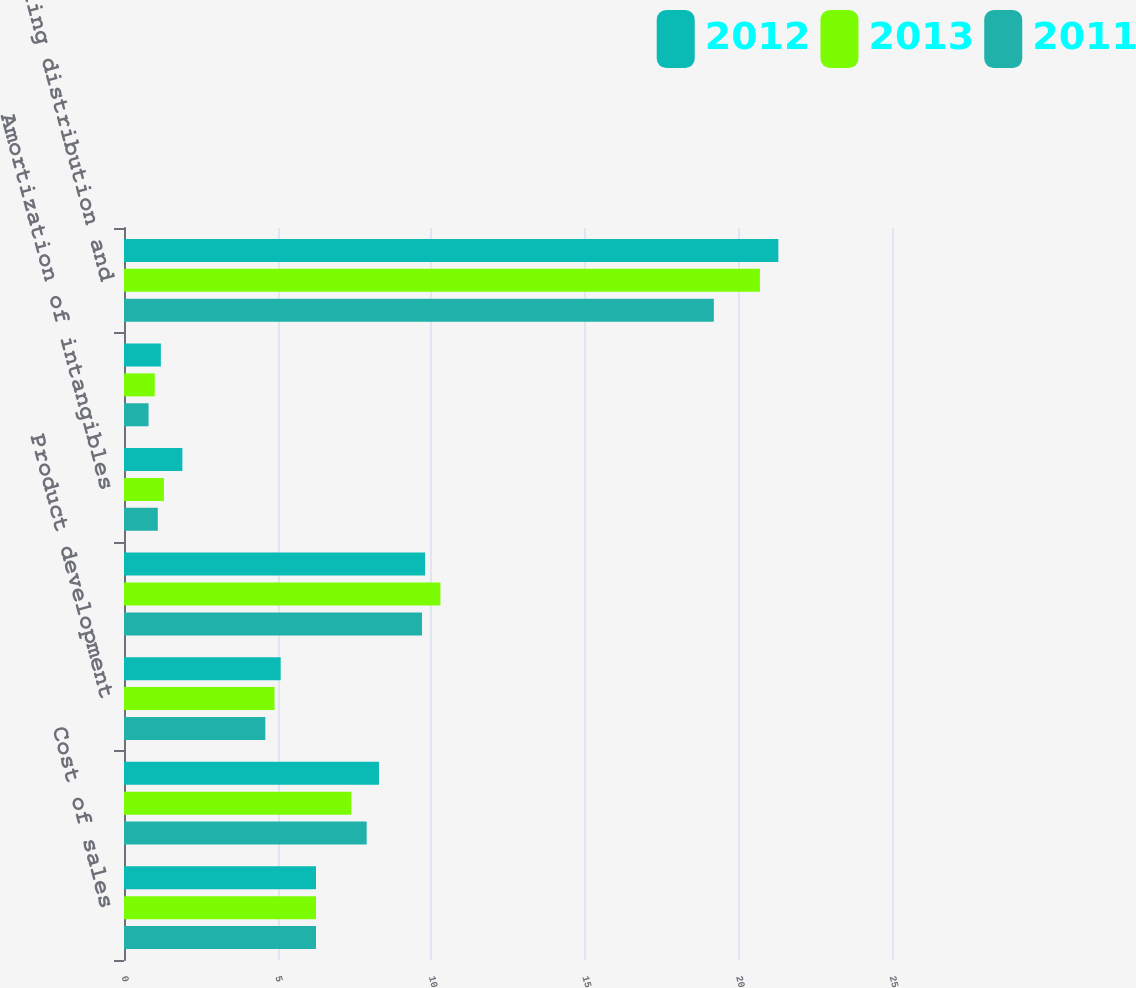Convert chart to OTSL. <chart><loc_0><loc_0><loc_500><loc_500><stacked_bar_chart><ecel><fcel>Cost of sales<fcel>Royalties<fcel>Product development<fcel>Advertising<fcel>Amortization of intangibles<fcel>Program production cost<fcel>Selling distribution and<nl><fcel>2012<fcel>6.25<fcel>8.3<fcel>5.1<fcel>9.8<fcel>1.9<fcel>1.2<fcel>21.3<nl><fcel>2013<fcel>6.25<fcel>7.4<fcel>4.9<fcel>10.3<fcel>1.3<fcel>1<fcel>20.7<nl><fcel>2011<fcel>6.25<fcel>7.9<fcel>4.6<fcel>9.7<fcel>1.1<fcel>0.8<fcel>19.2<nl></chart> 